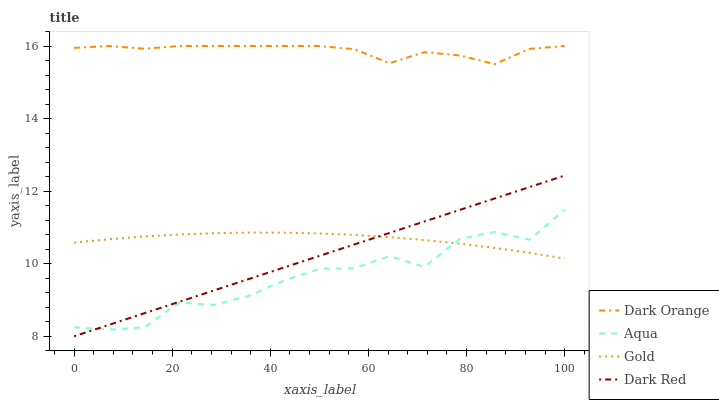Does Aqua have the minimum area under the curve?
Answer yes or no. Yes. Does Dark Orange have the maximum area under the curve?
Answer yes or no. Yes. Does Gold have the minimum area under the curve?
Answer yes or no. No. Does Gold have the maximum area under the curve?
Answer yes or no. No. Is Dark Red the smoothest?
Answer yes or no. Yes. Is Aqua the roughest?
Answer yes or no. Yes. Is Gold the smoothest?
Answer yes or no. No. Is Gold the roughest?
Answer yes or no. No. Does Dark Red have the lowest value?
Answer yes or no. Yes. Does Aqua have the lowest value?
Answer yes or no. No. Does Dark Orange have the highest value?
Answer yes or no. Yes. Does Aqua have the highest value?
Answer yes or no. No. Is Dark Red less than Dark Orange?
Answer yes or no. Yes. Is Dark Orange greater than Gold?
Answer yes or no. Yes. Does Dark Red intersect Gold?
Answer yes or no. Yes. Is Dark Red less than Gold?
Answer yes or no. No. Is Dark Red greater than Gold?
Answer yes or no. No. Does Dark Red intersect Dark Orange?
Answer yes or no. No. 